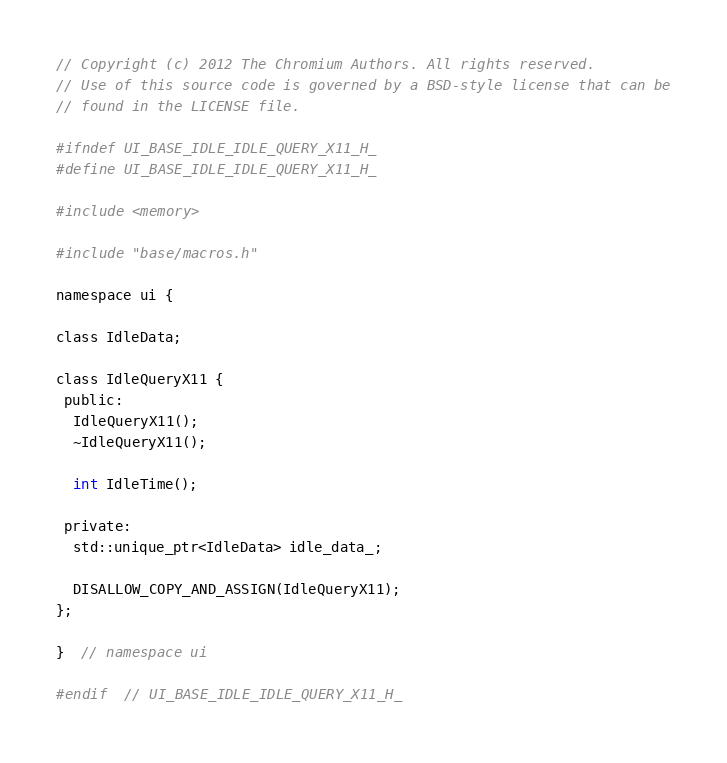Convert code to text. <code><loc_0><loc_0><loc_500><loc_500><_C_>// Copyright (c) 2012 The Chromium Authors. All rights reserved.
// Use of this source code is governed by a BSD-style license that can be
// found in the LICENSE file.

#ifndef UI_BASE_IDLE_IDLE_QUERY_X11_H_
#define UI_BASE_IDLE_IDLE_QUERY_X11_H_

#include <memory>

#include "base/macros.h"

namespace ui {

class IdleData;

class IdleQueryX11 {
 public:
  IdleQueryX11();
  ~IdleQueryX11();

  int IdleTime();

 private:
  std::unique_ptr<IdleData> idle_data_;

  DISALLOW_COPY_AND_ASSIGN(IdleQueryX11);
};

}  // namespace ui

#endif  // UI_BASE_IDLE_IDLE_QUERY_X11_H_
</code> 